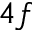<formula> <loc_0><loc_0><loc_500><loc_500>4 f</formula> 